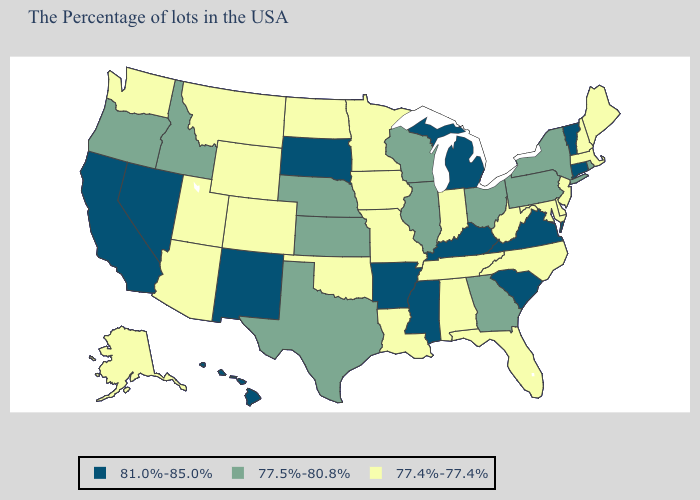Name the states that have a value in the range 77.5%-80.8%?
Quick response, please. Rhode Island, New York, Pennsylvania, Ohio, Georgia, Wisconsin, Illinois, Kansas, Nebraska, Texas, Idaho, Oregon. Name the states that have a value in the range 77.4%-77.4%?
Quick response, please. Maine, Massachusetts, New Hampshire, New Jersey, Delaware, Maryland, North Carolina, West Virginia, Florida, Indiana, Alabama, Tennessee, Louisiana, Missouri, Minnesota, Iowa, Oklahoma, North Dakota, Wyoming, Colorado, Utah, Montana, Arizona, Washington, Alaska. Name the states that have a value in the range 77.5%-80.8%?
Short answer required. Rhode Island, New York, Pennsylvania, Ohio, Georgia, Wisconsin, Illinois, Kansas, Nebraska, Texas, Idaho, Oregon. How many symbols are there in the legend?
Concise answer only. 3. Does Texas have the lowest value in the South?
Concise answer only. No. Name the states that have a value in the range 77.4%-77.4%?
Keep it brief. Maine, Massachusetts, New Hampshire, New Jersey, Delaware, Maryland, North Carolina, West Virginia, Florida, Indiana, Alabama, Tennessee, Louisiana, Missouri, Minnesota, Iowa, Oklahoma, North Dakota, Wyoming, Colorado, Utah, Montana, Arizona, Washington, Alaska. Does Utah have a lower value than Wisconsin?
Give a very brief answer. Yes. What is the value of Rhode Island?
Short answer required. 77.5%-80.8%. Name the states that have a value in the range 81.0%-85.0%?
Be succinct. Vermont, Connecticut, Virginia, South Carolina, Michigan, Kentucky, Mississippi, Arkansas, South Dakota, New Mexico, Nevada, California, Hawaii. Does Arizona have the lowest value in the USA?
Write a very short answer. Yes. What is the highest value in the USA?
Quick response, please. 81.0%-85.0%. What is the value of Massachusetts?
Short answer required. 77.4%-77.4%. Name the states that have a value in the range 77.4%-77.4%?
Write a very short answer. Maine, Massachusetts, New Hampshire, New Jersey, Delaware, Maryland, North Carolina, West Virginia, Florida, Indiana, Alabama, Tennessee, Louisiana, Missouri, Minnesota, Iowa, Oklahoma, North Dakota, Wyoming, Colorado, Utah, Montana, Arizona, Washington, Alaska. What is the value of Florida?
Short answer required. 77.4%-77.4%. 